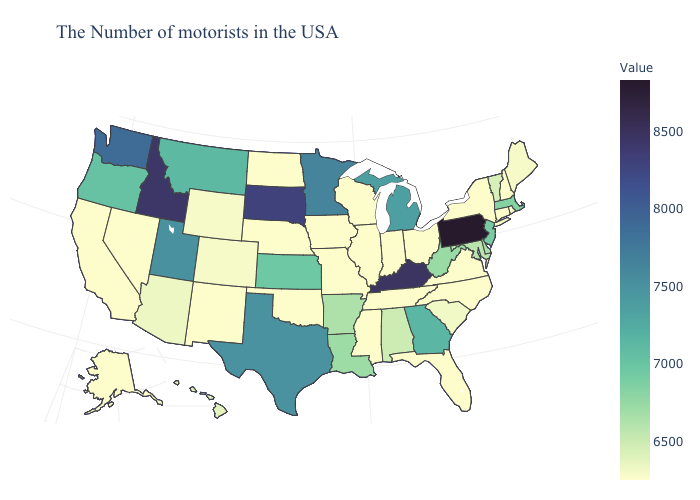Which states have the lowest value in the MidWest?
Keep it brief. Ohio, Indiana, Wisconsin, Illinois, Missouri, Iowa, Nebraska, North Dakota. Among the states that border Idaho , does Wyoming have the highest value?
Be succinct. No. Which states hav the highest value in the South?
Concise answer only. Kentucky. Among the states that border California , which have the lowest value?
Give a very brief answer. Nevada. 